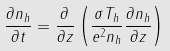<formula> <loc_0><loc_0><loc_500><loc_500>\frac { \partial n _ { h } } { \partial t } = \frac { \partial } { \partial z } \left ( \frac { \sigma T _ { h } } { e ^ { 2 } n _ { h } } \frac { \partial n _ { h } } { \partial z } \right )</formula> 